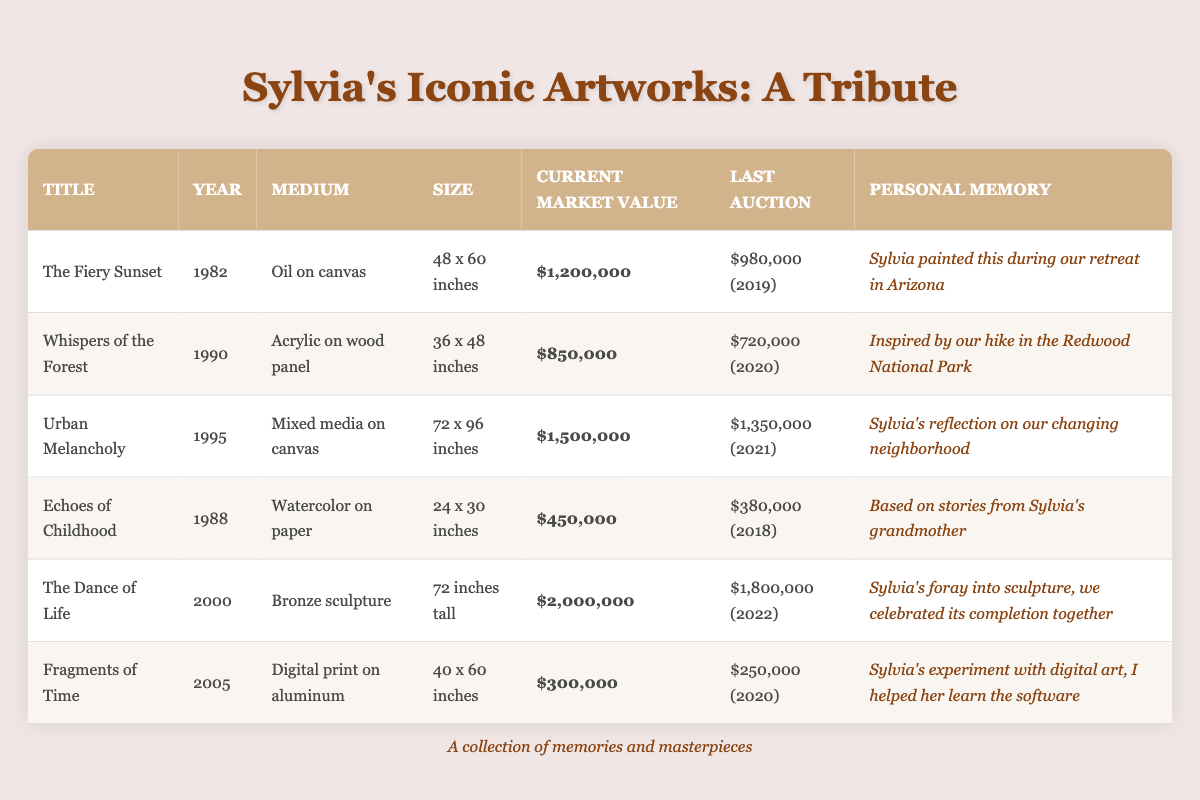What is the current market value of "Urban Melancholy"? The table lists the current market value of "Urban Melancholy" in the column titled "Current Market Value." It shows that the value is $1,500,000.
Answer: $1,500,000 Which artwork was auctioned for the highest price? Looking at the "Last Auction" column, "The Dance of Life" had an auction price of $1,800,000, which is the highest among all artworks listed.
Answer: The Dance of Life Is the medium of "Whispers of the Forest" an acrylic? In the "Medium" column for "Whispers of the Forest," it specifies that the medium is acrylic on wood panel, which confirms that the statement is true.
Answer: Yes What is the difference in market value between "The Fiery Sunset" and "Fragments of Time"? The market value of "The Fiery Sunset" is $1,200,000 and the value of "Fragments of Time" is $300,000. The difference is calculated as $1,200,000 - $300,000 = $900,000.
Answer: $900,000 How many artworks were created before the year 2000? By checking the "Year" column, we can count the artworks with years before 2000: "The Fiery Sunset" (1982), "Whispers of the Forest" (1990), "Echoes of Childhood" (1988), and "Urban Melancholy" (1995), which totals four artworks.
Answer: 4 What is the average current market value of all listed artworks? To calculate the average, we first sum the current market values: $1,200,000 + $850,000 + $1,500,000 + $450,000 + $2,000,000 + $300,000 = $6,300,000. Then divide by the number of artworks (6): $6,300,000 / 6 = $1,050,000.
Answer: $1,050,000 Did any of Sylvia's artworks reflect personal experiences? The "Personal Memory" column lists reflections related to each artwork, such as hike inspirations and personal stories which indicate that all artworks indeed contained personal experiences, confirming the statement to be true.
Answer: Yes Which artwork has the smallest size? From the "Size" column, "Echoes of Childhood" is listed as 24 x 30 inches, which is smaller than the sizes of the other artworks, making it the artwork with the smallest size.
Answer: Echoes of Childhood What year was "The Dance of Life" auctioned? The "Last Auction" column shows that "The Dance of Life" was auctioned in 2022.
Answer: 2022 